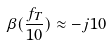<formula> <loc_0><loc_0><loc_500><loc_500>\beta ( \frac { f _ { T } } { 1 0 } ) \approx - j 1 0</formula> 